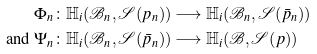Convert formula to latex. <formula><loc_0><loc_0><loc_500><loc_500>\Phi _ { n } & \colon \mathbb { H } _ { i } ( \mathcal { B } _ { n } , \mathcal { S } ( p _ { n } ) ) \longrightarrow \mathbb { H } _ { i } ( \mathcal { B } _ { n } , \mathcal { S } ( \bar { p } _ { n } ) ) \\ \text {and } \Psi _ { n } & \colon \mathbb { H } _ { i } ( \mathcal { B } _ { n } , \mathcal { S } ( \bar { p } _ { n } ) ) \longrightarrow \mathbb { H } _ { i } ( \mathcal { B } , \mathcal { S } ( p ) )</formula> 